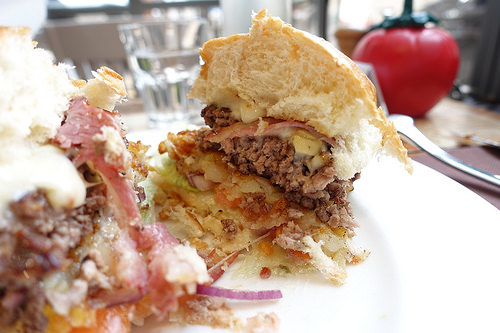<image>
Can you confirm if the food is to the right of the spoon? No. The food is not to the right of the spoon. The horizontal positioning shows a different relationship. 